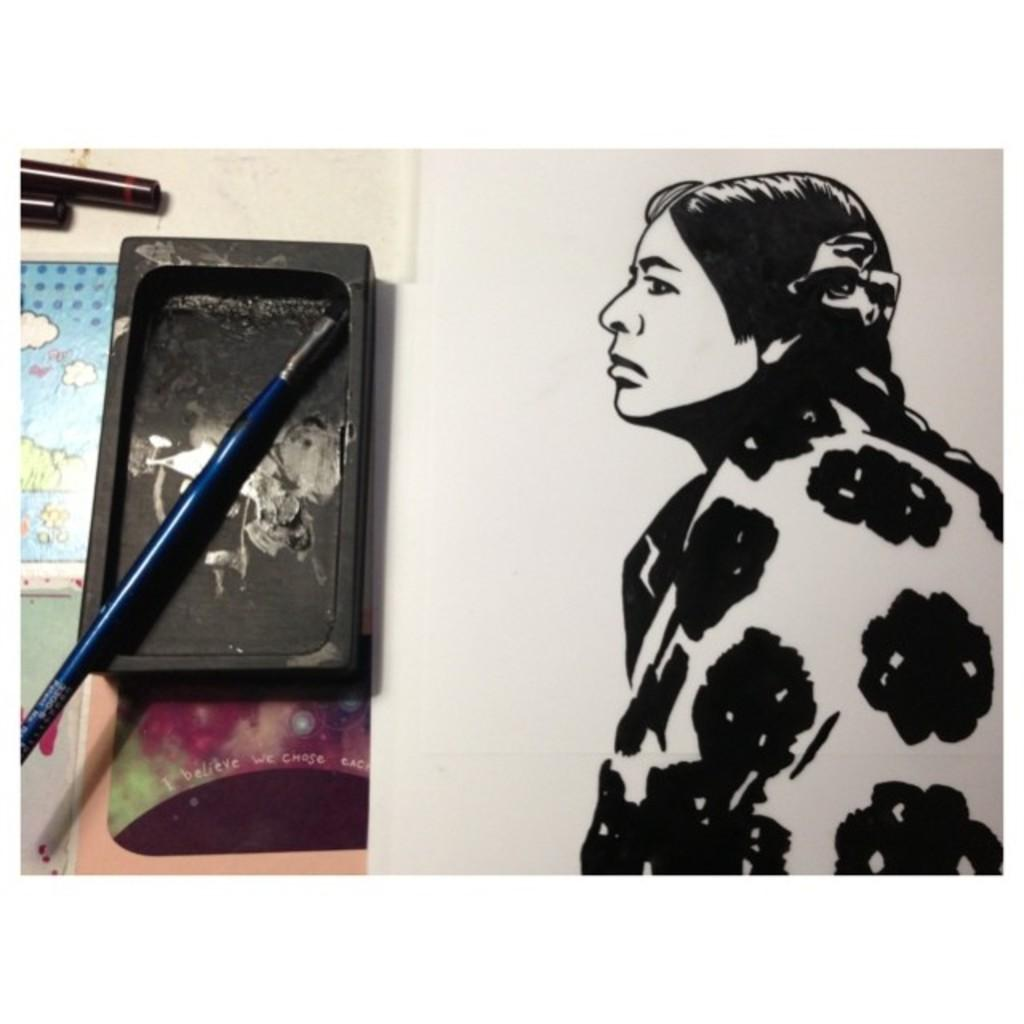What is depicted in the painting that is visible in the image? There is a painting of a woman in the image. What objects are on the table in the image? There is a tray and a brush on the table in the image. Where is the playground located in the image? There is no playground present in the image. What type of ship can be seen sailing in the background of the image? There is no ship visible in the image; it only features a painting of a woman and objects on a table. 